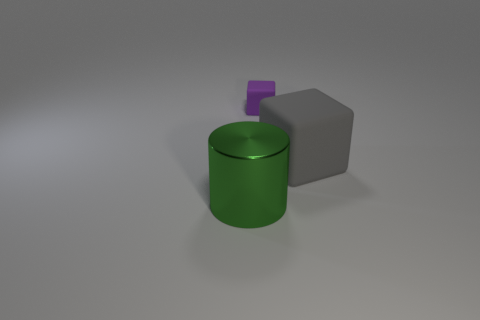Add 1 red things. How many objects exist? 4 Subtract all cubes. How many objects are left? 1 Add 3 green metal cylinders. How many green metal cylinders are left? 4 Add 2 big blue metallic cylinders. How many big blue metallic cylinders exist? 2 Subtract 1 green cylinders. How many objects are left? 2 Subtract all big green shiny objects. Subtract all purple matte things. How many objects are left? 1 